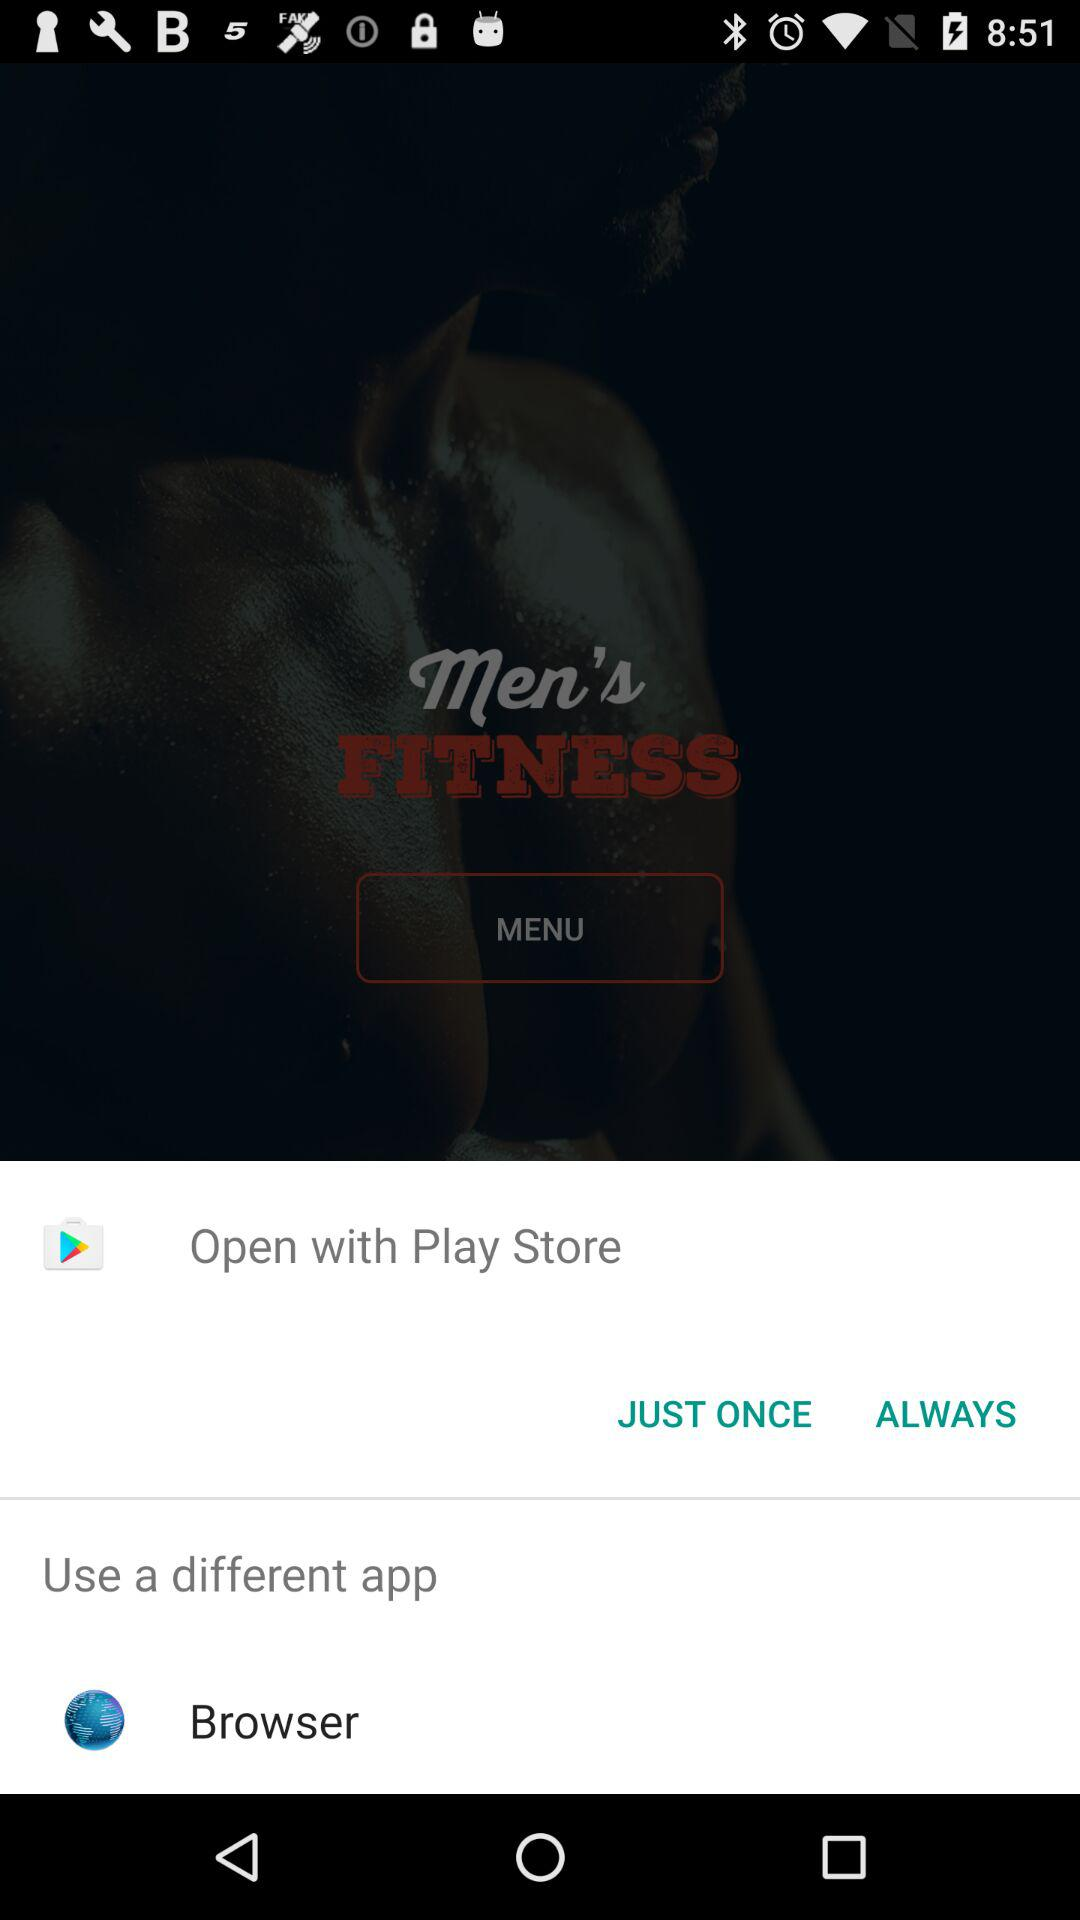What options can be used to open? The options used to open are "Play Store" and "Browser". 